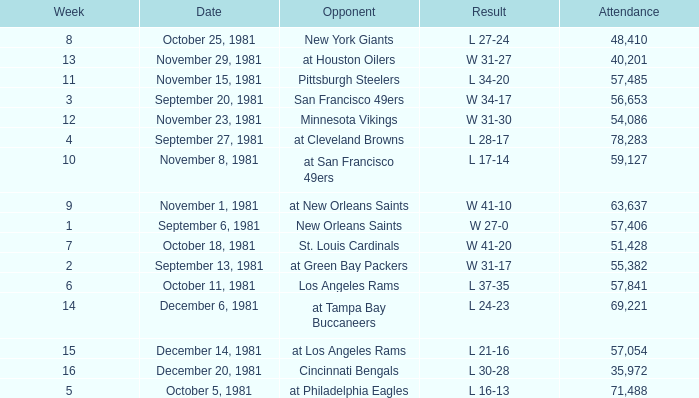On what date did the team play againt the New Orleans Saints? September 6, 1981. 